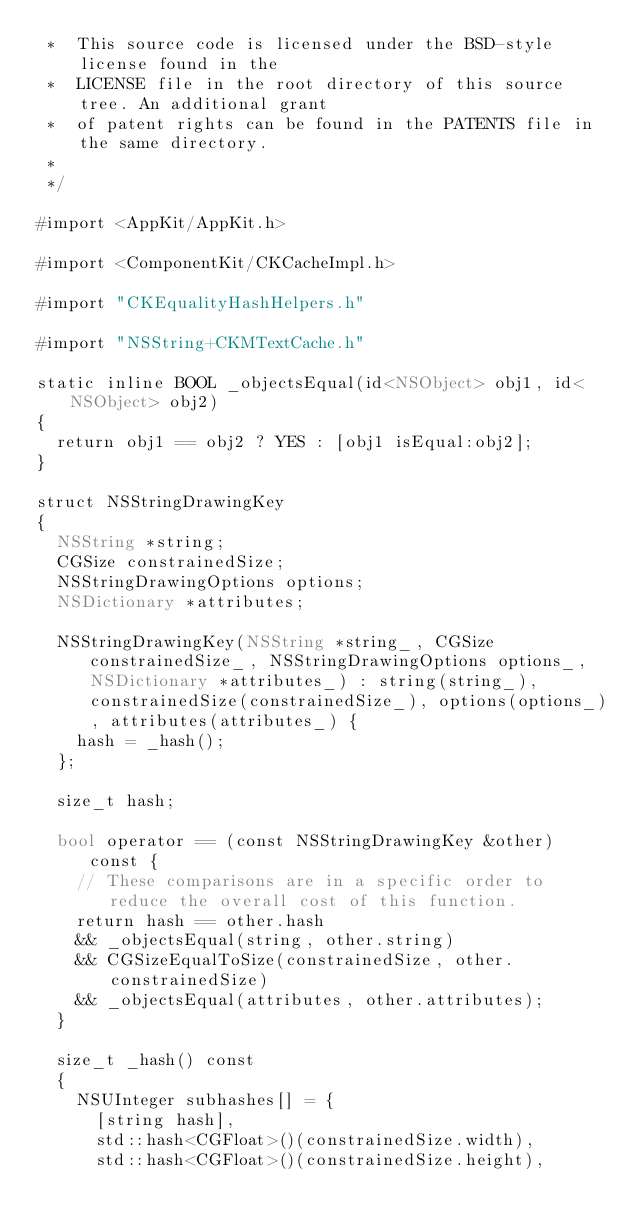<code> <loc_0><loc_0><loc_500><loc_500><_ObjectiveC_> *  This source code is licensed under the BSD-style license found in the
 *  LICENSE file in the root directory of this source tree. An additional grant
 *  of patent rights can be found in the PATENTS file in the same directory.
 *
 */

#import <AppKit/AppKit.h>

#import <ComponentKit/CKCacheImpl.h>

#import "CKEqualityHashHelpers.h"

#import "NSString+CKMTextCache.h"

static inline BOOL _objectsEqual(id<NSObject> obj1, id<NSObject> obj2)
{
  return obj1 == obj2 ? YES : [obj1 isEqual:obj2];
}

struct NSStringDrawingKey
{
  NSString *string;
  CGSize constrainedSize;
  NSStringDrawingOptions options;
  NSDictionary *attributes;

  NSStringDrawingKey(NSString *string_, CGSize constrainedSize_, NSStringDrawingOptions options_, NSDictionary *attributes_) : string(string_), constrainedSize(constrainedSize_), options(options_), attributes(attributes_) {
    hash = _hash();
  };

  size_t hash;

  bool operator == (const NSStringDrawingKey &other) const {
    // These comparisons are in a specific order to reduce the overall cost of this function.
    return hash == other.hash
    && _objectsEqual(string, other.string)
    && CGSizeEqualToSize(constrainedSize, other.constrainedSize)
    && _objectsEqual(attributes, other.attributes);
  }

  size_t _hash() const
  {
    NSUInteger subhashes[] = {
      [string hash],
      std::hash<CGFloat>()(constrainedSize.width),
      std::hash<CGFloat>()(constrainedSize.height),</code> 